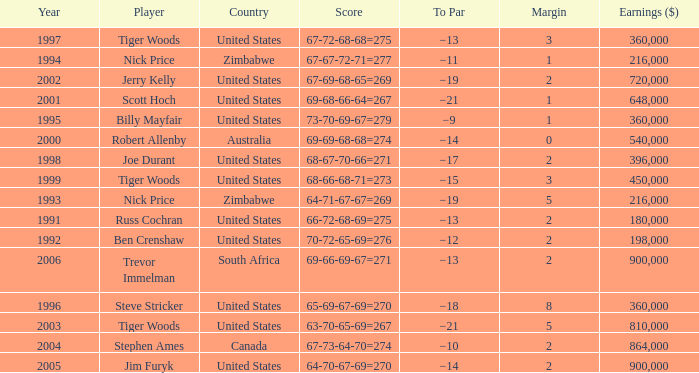Which To Par has Earnings ($) larger than 360,000, and a Year larger than 1998, and a Country of united states, and a Score of 69-68-66-64=267? −21. 